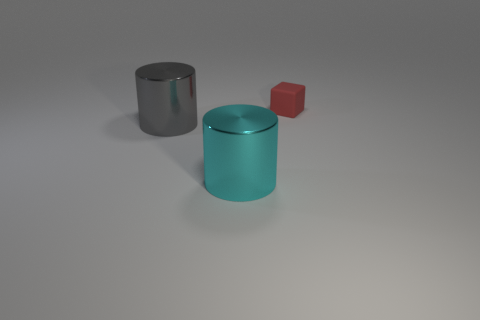Add 1 cubes. How many objects exist? 4 Subtract all blocks. How many objects are left? 2 Subtract 0 brown spheres. How many objects are left? 3 Subtract all gray things. Subtract all gray shiny things. How many objects are left? 1 Add 2 tiny red things. How many tiny red things are left? 3 Add 1 shiny objects. How many shiny objects exist? 3 